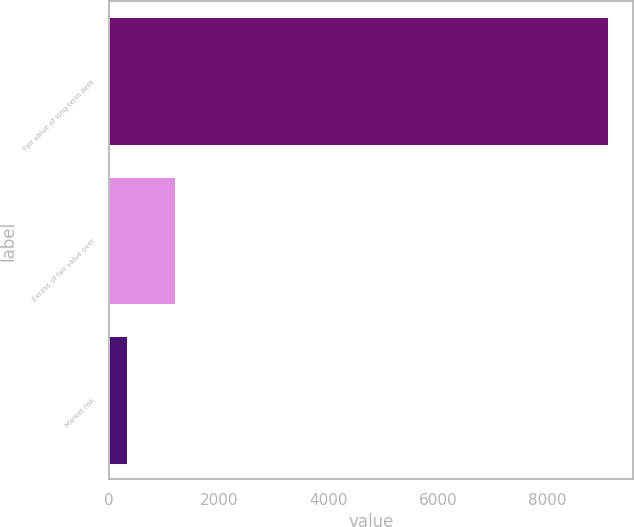Convert chart. <chart><loc_0><loc_0><loc_500><loc_500><bar_chart><fcel>Fair value of long-term debt<fcel>Excess of fair value over<fcel>Market risk<nl><fcel>9108<fcel>1210.5<fcel>333<nl></chart> 